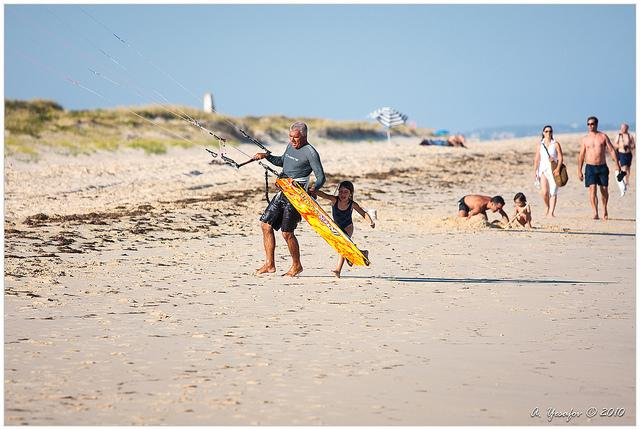What is the man helping the young woman with in the sand?

Choices:
A) collect turtles
B) collect water
C) lay towel
D) build sandcastle build sandcastle 